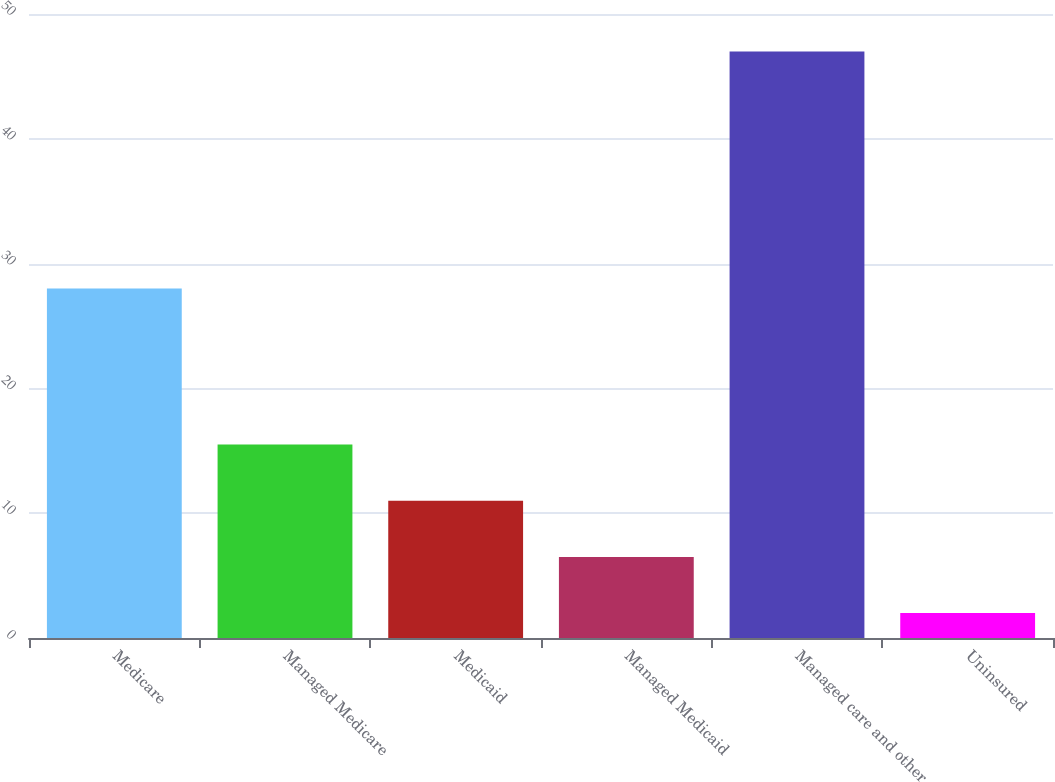<chart> <loc_0><loc_0><loc_500><loc_500><bar_chart><fcel>Medicare<fcel>Managed Medicare<fcel>Medicaid<fcel>Managed Medicaid<fcel>Managed care and other<fcel>Uninsured<nl><fcel>28<fcel>15.5<fcel>11<fcel>6.5<fcel>47<fcel>2<nl></chart> 